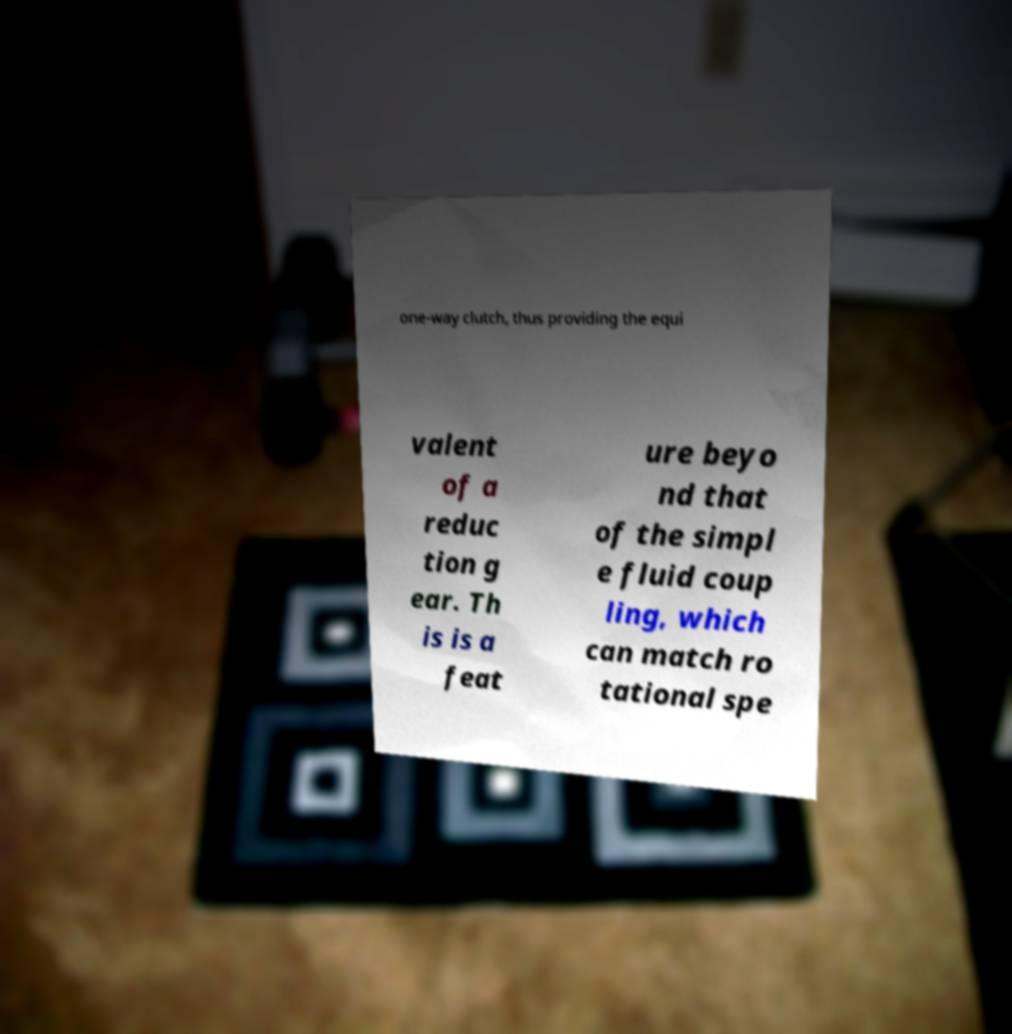Can you read and provide the text displayed in the image?This photo seems to have some interesting text. Can you extract and type it out for me? one-way clutch, thus providing the equi valent of a reduc tion g ear. Th is is a feat ure beyo nd that of the simpl e fluid coup ling, which can match ro tational spe 